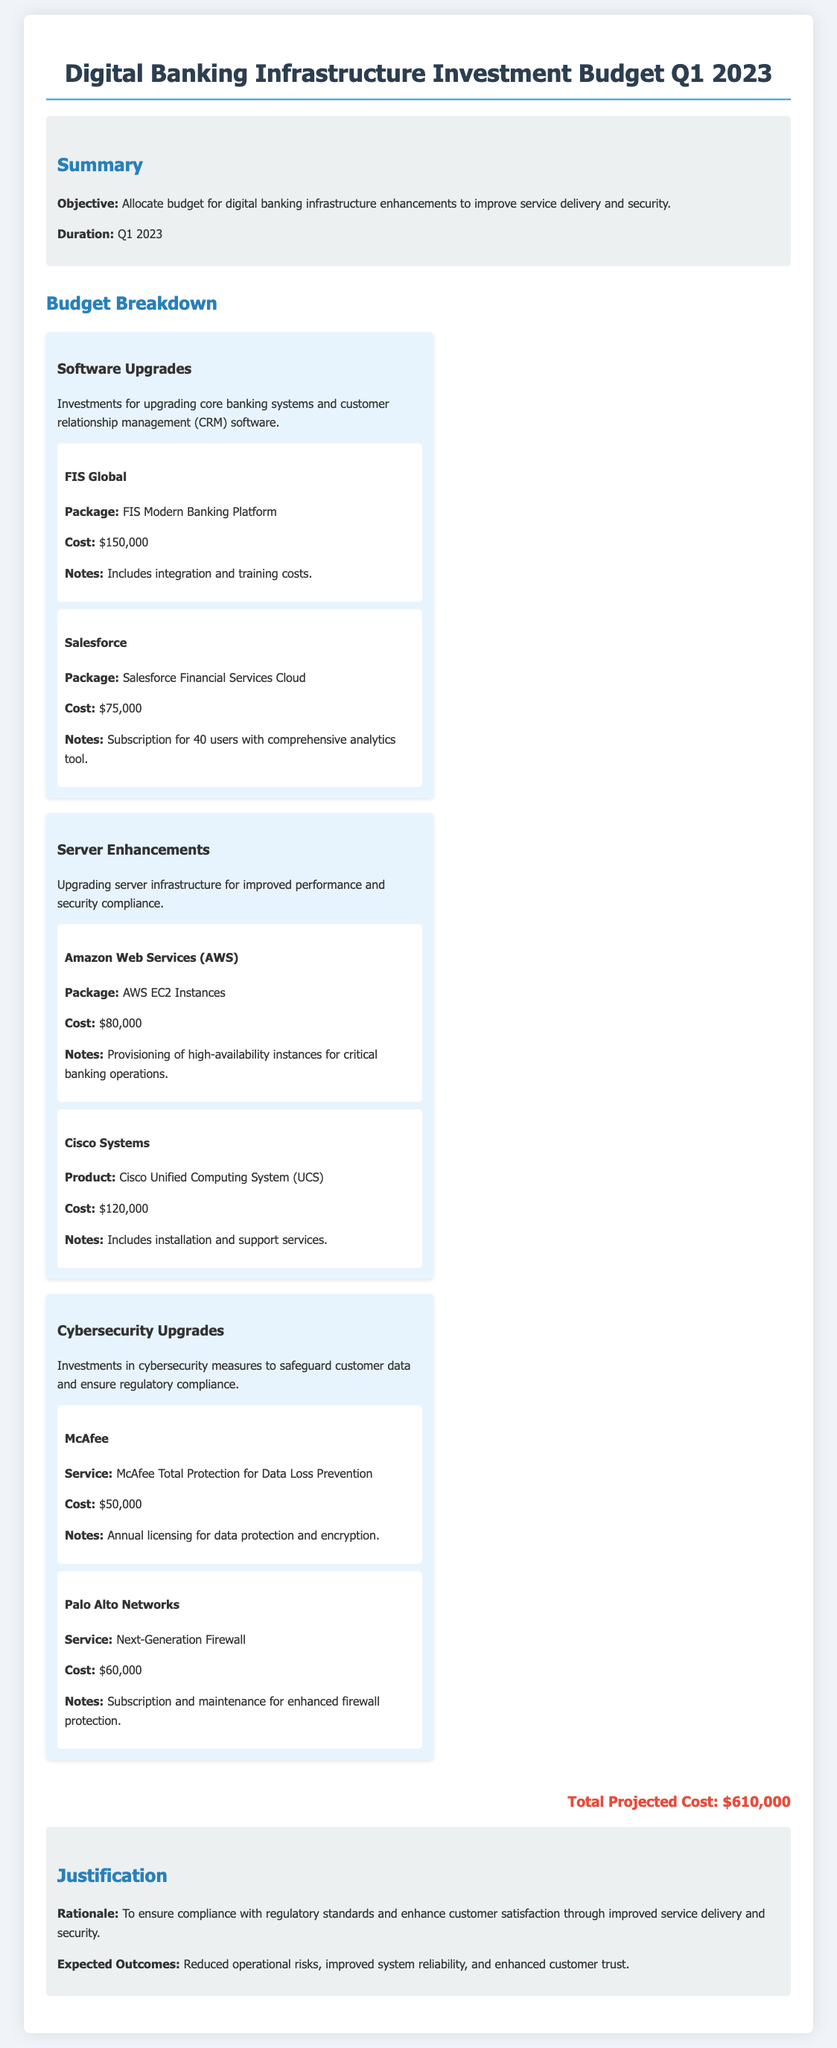what is the total projected cost? The total projected cost is clearly stated at the end of the budget document, which sums up all the expenses listed.
Answer: $610,000 who is the vendor for core banking system upgrades? The document lists FIS Global as the vendor providing the core banking system upgrade package.
Answer: FIS Global how much is allocated for the Salesforce Financial Services Cloud? The budget specifically mentions the cost for the Salesforce package under software upgrades.
Answer: $75,000 what is the purpose of the server enhancements? The document explains that server enhancements are aimed at improving performance and security compliance.
Answer: improved performance and security compliance what is included in the cost for Cisco Unified Computing System? The budget provides insights into what the cost covers, including installation and support services.
Answer: installation and support services what is the name of the cybersecurity service from McAfee? The document specifies the name of the cybersecurity service offered by McAfee included in the budget.
Answer: McAfee Total Protection for Data Loss Prevention how many users does the Salesforce subscription cover? The document explicitly states the number of users covered under the Salesforce subscription.
Answer: 40 users what is the rationale behind the infrastructure investment? The justification section outlines the reasoning for the investment to ensure compliance and enhance service delivery.
Answer: compliance with regulatory standards and enhance customer satisfaction which package has the highest cost under software upgrades? The budget breakdown lists both software upgrades and their respective costs, identifying the package with the highest expense.
Answer: FIS Modern Banking Platform 